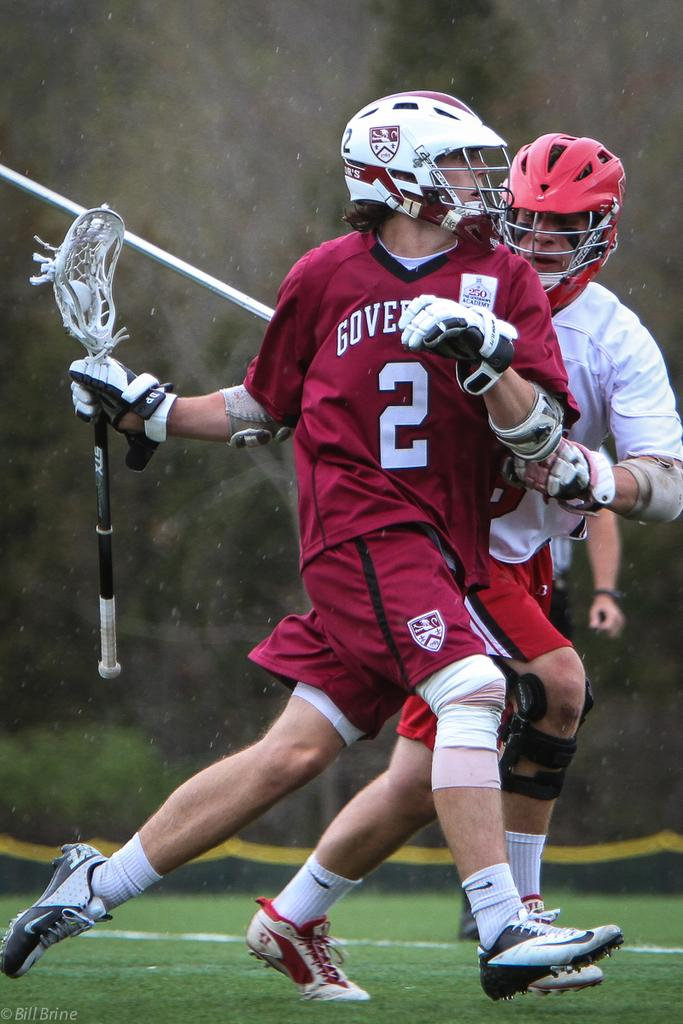<image>
Share a concise interpretation of the image provided. An athlete wearing a number 2 jersey tries to escape his blocker 